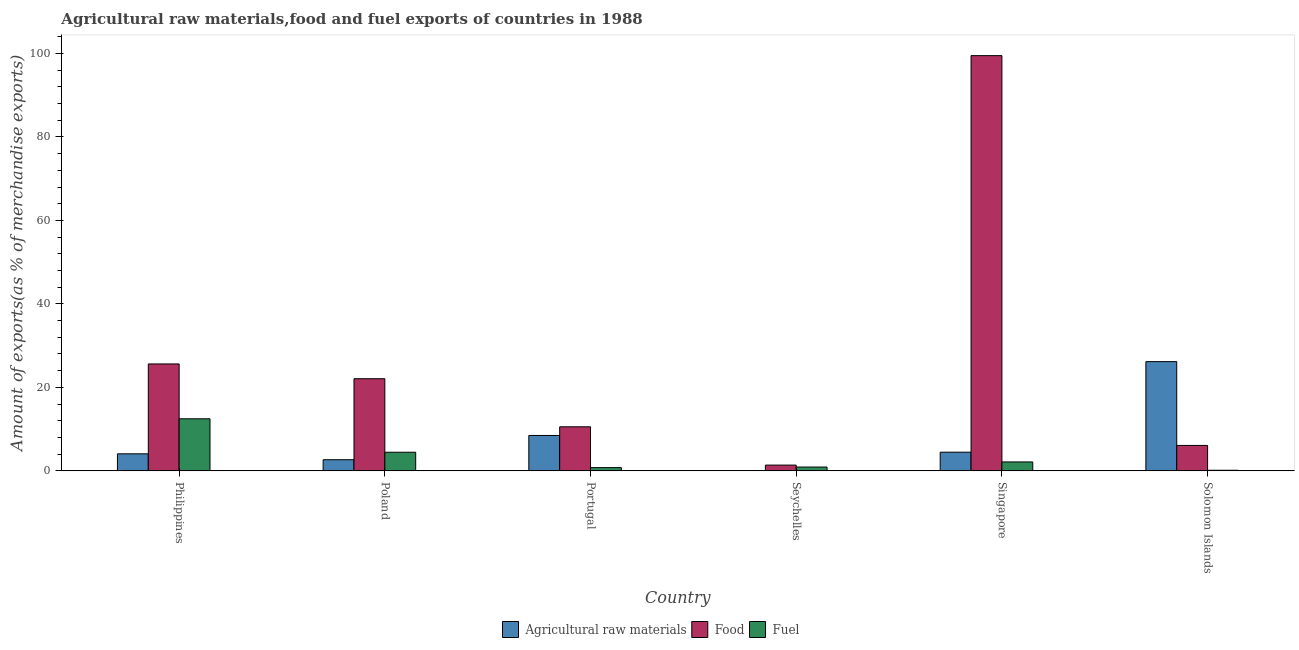How many different coloured bars are there?
Offer a terse response. 3. Are the number of bars per tick equal to the number of legend labels?
Give a very brief answer. Yes. How many bars are there on the 2nd tick from the right?
Your answer should be very brief. 3. What is the label of the 5th group of bars from the left?
Your answer should be very brief. Singapore. What is the percentage of food exports in Poland?
Give a very brief answer. 22.07. Across all countries, what is the maximum percentage of raw materials exports?
Your response must be concise. 26.16. Across all countries, what is the minimum percentage of raw materials exports?
Keep it short and to the point. 0.05. In which country was the percentage of raw materials exports maximum?
Ensure brevity in your answer.  Solomon Islands. In which country was the percentage of food exports minimum?
Make the answer very short. Seychelles. What is the total percentage of raw materials exports in the graph?
Offer a terse response. 45.89. What is the difference between the percentage of raw materials exports in Philippines and that in Solomon Islands?
Your answer should be very brief. -22.09. What is the difference between the percentage of raw materials exports in Seychelles and the percentage of fuel exports in Philippines?
Provide a succinct answer. -12.42. What is the average percentage of food exports per country?
Give a very brief answer. 27.53. What is the difference between the percentage of fuel exports and percentage of raw materials exports in Philippines?
Provide a short and direct response. 8.39. What is the ratio of the percentage of raw materials exports in Philippines to that in Solomon Islands?
Offer a terse response. 0.16. What is the difference between the highest and the second highest percentage of fuel exports?
Keep it short and to the point. 8.02. What is the difference between the highest and the lowest percentage of fuel exports?
Your answer should be compact. 12.33. Is the sum of the percentage of fuel exports in Philippines and Singapore greater than the maximum percentage of food exports across all countries?
Keep it short and to the point. No. What does the 3rd bar from the left in Portugal represents?
Keep it short and to the point. Fuel. What does the 3rd bar from the right in Portugal represents?
Keep it short and to the point. Agricultural raw materials. How many bars are there?
Give a very brief answer. 18. Are all the bars in the graph horizontal?
Give a very brief answer. No. Are the values on the major ticks of Y-axis written in scientific E-notation?
Offer a very short reply. No. Does the graph contain any zero values?
Make the answer very short. No. Does the graph contain grids?
Provide a succinct answer. No. How many legend labels are there?
Offer a terse response. 3. What is the title of the graph?
Give a very brief answer. Agricultural raw materials,food and fuel exports of countries in 1988. What is the label or title of the Y-axis?
Your answer should be compact. Amount of exports(as % of merchandise exports). What is the Amount of exports(as % of merchandise exports) of Agricultural raw materials in Philippines?
Provide a short and direct response. 4.08. What is the Amount of exports(as % of merchandise exports) of Food in Philippines?
Make the answer very short. 25.62. What is the Amount of exports(as % of merchandise exports) in Fuel in Philippines?
Provide a succinct answer. 12.47. What is the Amount of exports(as % of merchandise exports) in Agricultural raw materials in Poland?
Provide a succinct answer. 2.66. What is the Amount of exports(as % of merchandise exports) in Food in Poland?
Provide a short and direct response. 22.07. What is the Amount of exports(as % of merchandise exports) in Fuel in Poland?
Give a very brief answer. 4.45. What is the Amount of exports(as % of merchandise exports) in Agricultural raw materials in Portugal?
Offer a terse response. 8.47. What is the Amount of exports(as % of merchandise exports) of Food in Portugal?
Keep it short and to the point. 10.55. What is the Amount of exports(as % of merchandise exports) of Fuel in Portugal?
Offer a very short reply. 0.77. What is the Amount of exports(as % of merchandise exports) in Agricultural raw materials in Seychelles?
Give a very brief answer. 0.05. What is the Amount of exports(as % of merchandise exports) of Food in Seychelles?
Make the answer very short. 1.37. What is the Amount of exports(as % of merchandise exports) in Fuel in Seychelles?
Give a very brief answer. 0.91. What is the Amount of exports(as % of merchandise exports) of Agricultural raw materials in Singapore?
Your answer should be very brief. 4.47. What is the Amount of exports(as % of merchandise exports) of Food in Singapore?
Your answer should be compact. 99.49. What is the Amount of exports(as % of merchandise exports) of Fuel in Singapore?
Offer a terse response. 2.13. What is the Amount of exports(as % of merchandise exports) in Agricultural raw materials in Solomon Islands?
Offer a very short reply. 26.16. What is the Amount of exports(as % of merchandise exports) in Food in Solomon Islands?
Give a very brief answer. 6.09. What is the Amount of exports(as % of merchandise exports) in Fuel in Solomon Islands?
Provide a short and direct response. 0.14. Across all countries, what is the maximum Amount of exports(as % of merchandise exports) of Agricultural raw materials?
Give a very brief answer. 26.16. Across all countries, what is the maximum Amount of exports(as % of merchandise exports) of Food?
Make the answer very short. 99.49. Across all countries, what is the maximum Amount of exports(as % of merchandise exports) of Fuel?
Keep it short and to the point. 12.47. Across all countries, what is the minimum Amount of exports(as % of merchandise exports) of Agricultural raw materials?
Offer a terse response. 0.05. Across all countries, what is the minimum Amount of exports(as % of merchandise exports) of Food?
Offer a very short reply. 1.37. Across all countries, what is the minimum Amount of exports(as % of merchandise exports) in Fuel?
Offer a terse response. 0.14. What is the total Amount of exports(as % of merchandise exports) of Agricultural raw materials in the graph?
Offer a terse response. 45.89. What is the total Amount of exports(as % of merchandise exports) of Food in the graph?
Your answer should be compact. 165.19. What is the total Amount of exports(as % of merchandise exports) of Fuel in the graph?
Provide a succinct answer. 20.87. What is the difference between the Amount of exports(as % of merchandise exports) of Agricultural raw materials in Philippines and that in Poland?
Your answer should be very brief. 1.42. What is the difference between the Amount of exports(as % of merchandise exports) of Food in Philippines and that in Poland?
Give a very brief answer. 3.54. What is the difference between the Amount of exports(as % of merchandise exports) in Fuel in Philippines and that in Poland?
Offer a very short reply. 8.02. What is the difference between the Amount of exports(as % of merchandise exports) of Agricultural raw materials in Philippines and that in Portugal?
Your answer should be very brief. -4.4. What is the difference between the Amount of exports(as % of merchandise exports) in Food in Philippines and that in Portugal?
Your response must be concise. 15.07. What is the difference between the Amount of exports(as % of merchandise exports) of Fuel in Philippines and that in Portugal?
Your response must be concise. 11.7. What is the difference between the Amount of exports(as % of merchandise exports) in Agricultural raw materials in Philippines and that in Seychelles?
Offer a terse response. 4.03. What is the difference between the Amount of exports(as % of merchandise exports) of Food in Philippines and that in Seychelles?
Ensure brevity in your answer.  24.24. What is the difference between the Amount of exports(as % of merchandise exports) of Fuel in Philippines and that in Seychelles?
Provide a short and direct response. 11.56. What is the difference between the Amount of exports(as % of merchandise exports) of Agricultural raw materials in Philippines and that in Singapore?
Your answer should be very brief. -0.39. What is the difference between the Amount of exports(as % of merchandise exports) of Food in Philippines and that in Singapore?
Provide a short and direct response. -73.87. What is the difference between the Amount of exports(as % of merchandise exports) in Fuel in Philippines and that in Singapore?
Make the answer very short. 10.34. What is the difference between the Amount of exports(as % of merchandise exports) in Agricultural raw materials in Philippines and that in Solomon Islands?
Your answer should be compact. -22.09. What is the difference between the Amount of exports(as % of merchandise exports) of Food in Philippines and that in Solomon Islands?
Give a very brief answer. 19.53. What is the difference between the Amount of exports(as % of merchandise exports) of Fuel in Philippines and that in Solomon Islands?
Offer a very short reply. 12.33. What is the difference between the Amount of exports(as % of merchandise exports) of Agricultural raw materials in Poland and that in Portugal?
Ensure brevity in your answer.  -5.81. What is the difference between the Amount of exports(as % of merchandise exports) of Food in Poland and that in Portugal?
Your answer should be very brief. 11.52. What is the difference between the Amount of exports(as % of merchandise exports) of Fuel in Poland and that in Portugal?
Make the answer very short. 3.68. What is the difference between the Amount of exports(as % of merchandise exports) of Agricultural raw materials in Poland and that in Seychelles?
Keep it short and to the point. 2.61. What is the difference between the Amount of exports(as % of merchandise exports) of Food in Poland and that in Seychelles?
Offer a terse response. 20.7. What is the difference between the Amount of exports(as % of merchandise exports) of Fuel in Poland and that in Seychelles?
Offer a very short reply. 3.54. What is the difference between the Amount of exports(as % of merchandise exports) of Agricultural raw materials in Poland and that in Singapore?
Offer a terse response. -1.8. What is the difference between the Amount of exports(as % of merchandise exports) in Food in Poland and that in Singapore?
Provide a short and direct response. -77.42. What is the difference between the Amount of exports(as % of merchandise exports) of Fuel in Poland and that in Singapore?
Make the answer very short. 2.32. What is the difference between the Amount of exports(as % of merchandise exports) in Agricultural raw materials in Poland and that in Solomon Islands?
Your answer should be compact. -23.5. What is the difference between the Amount of exports(as % of merchandise exports) of Food in Poland and that in Solomon Islands?
Offer a very short reply. 15.99. What is the difference between the Amount of exports(as % of merchandise exports) of Fuel in Poland and that in Solomon Islands?
Keep it short and to the point. 4.32. What is the difference between the Amount of exports(as % of merchandise exports) in Agricultural raw materials in Portugal and that in Seychelles?
Your answer should be very brief. 8.43. What is the difference between the Amount of exports(as % of merchandise exports) in Food in Portugal and that in Seychelles?
Offer a terse response. 9.18. What is the difference between the Amount of exports(as % of merchandise exports) in Fuel in Portugal and that in Seychelles?
Ensure brevity in your answer.  -0.14. What is the difference between the Amount of exports(as % of merchandise exports) in Agricultural raw materials in Portugal and that in Singapore?
Ensure brevity in your answer.  4.01. What is the difference between the Amount of exports(as % of merchandise exports) in Food in Portugal and that in Singapore?
Offer a terse response. -88.94. What is the difference between the Amount of exports(as % of merchandise exports) of Fuel in Portugal and that in Singapore?
Your response must be concise. -1.36. What is the difference between the Amount of exports(as % of merchandise exports) in Agricultural raw materials in Portugal and that in Solomon Islands?
Give a very brief answer. -17.69. What is the difference between the Amount of exports(as % of merchandise exports) of Food in Portugal and that in Solomon Islands?
Keep it short and to the point. 4.46. What is the difference between the Amount of exports(as % of merchandise exports) of Fuel in Portugal and that in Solomon Islands?
Offer a terse response. 0.64. What is the difference between the Amount of exports(as % of merchandise exports) of Agricultural raw materials in Seychelles and that in Singapore?
Provide a succinct answer. -4.42. What is the difference between the Amount of exports(as % of merchandise exports) of Food in Seychelles and that in Singapore?
Your answer should be compact. -98.12. What is the difference between the Amount of exports(as % of merchandise exports) in Fuel in Seychelles and that in Singapore?
Provide a short and direct response. -1.22. What is the difference between the Amount of exports(as % of merchandise exports) in Agricultural raw materials in Seychelles and that in Solomon Islands?
Your answer should be compact. -26.12. What is the difference between the Amount of exports(as % of merchandise exports) in Food in Seychelles and that in Solomon Islands?
Your response must be concise. -4.71. What is the difference between the Amount of exports(as % of merchandise exports) in Fuel in Seychelles and that in Solomon Islands?
Your response must be concise. 0.77. What is the difference between the Amount of exports(as % of merchandise exports) of Agricultural raw materials in Singapore and that in Solomon Islands?
Your answer should be very brief. -21.7. What is the difference between the Amount of exports(as % of merchandise exports) in Food in Singapore and that in Solomon Islands?
Offer a very short reply. 93.4. What is the difference between the Amount of exports(as % of merchandise exports) in Fuel in Singapore and that in Solomon Islands?
Your answer should be very brief. 1.99. What is the difference between the Amount of exports(as % of merchandise exports) in Agricultural raw materials in Philippines and the Amount of exports(as % of merchandise exports) in Food in Poland?
Your response must be concise. -18. What is the difference between the Amount of exports(as % of merchandise exports) of Agricultural raw materials in Philippines and the Amount of exports(as % of merchandise exports) of Fuel in Poland?
Make the answer very short. -0.38. What is the difference between the Amount of exports(as % of merchandise exports) of Food in Philippines and the Amount of exports(as % of merchandise exports) of Fuel in Poland?
Your answer should be very brief. 21.16. What is the difference between the Amount of exports(as % of merchandise exports) of Agricultural raw materials in Philippines and the Amount of exports(as % of merchandise exports) of Food in Portugal?
Your answer should be very brief. -6.47. What is the difference between the Amount of exports(as % of merchandise exports) of Agricultural raw materials in Philippines and the Amount of exports(as % of merchandise exports) of Fuel in Portugal?
Keep it short and to the point. 3.31. What is the difference between the Amount of exports(as % of merchandise exports) in Food in Philippines and the Amount of exports(as % of merchandise exports) in Fuel in Portugal?
Keep it short and to the point. 24.84. What is the difference between the Amount of exports(as % of merchandise exports) of Agricultural raw materials in Philippines and the Amount of exports(as % of merchandise exports) of Food in Seychelles?
Keep it short and to the point. 2.7. What is the difference between the Amount of exports(as % of merchandise exports) in Agricultural raw materials in Philippines and the Amount of exports(as % of merchandise exports) in Fuel in Seychelles?
Make the answer very short. 3.17. What is the difference between the Amount of exports(as % of merchandise exports) in Food in Philippines and the Amount of exports(as % of merchandise exports) in Fuel in Seychelles?
Provide a short and direct response. 24.71. What is the difference between the Amount of exports(as % of merchandise exports) of Agricultural raw materials in Philippines and the Amount of exports(as % of merchandise exports) of Food in Singapore?
Keep it short and to the point. -95.41. What is the difference between the Amount of exports(as % of merchandise exports) in Agricultural raw materials in Philippines and the Amount of exports(as % of merchandise exports) in Fuel in Singapore?
Offer a terse response. 1.95. What is the difference between the Amount of exports(as % of merchandise exports) in Food in Philippines and the Amount of exports(as % of merchandise exports) in Fuel in Singapore?
Provide a short and direct response. 23.49. What is the difference between the Amount of exports(as % of merchandise exports) of Agricultural raw materials in Philippines and the Amount of exports(as % of merchandise exports) of Food in Solomon Islands?
Your answer should be very brief. -2.01. What is the difference between the Amount of exports(as % of merchandise exports) in Agricultural raw materials in Philippines and the Amount of exports(as % of merchandise exports) in Fuel in Solomon Islands?
Make the answer very short. 3.94. What is the difference between the Amount of exports(as % of merchandise exports) of Food in Philippines and the Amount of exports(as % of merchandise exports) of Fuel in Solomon Islands?
Your answer should be compact. 25.48. What is the difference between the Amount of exports(as % of merchandise exports) of Agricultural raw materials in Poland and the Amount of exports(as % of merchandise exports) of Food in Portugal?
Provide a short and direct response. -7.89. What is the difference between the Amount of exports(as % of merchandise exports) in Agricultural raw materials in Poland and the Amount of exports(as % of merchandise exports) in Fuel in Portugal?
Offer a terse response. 1.89. What is the difference between the Amount of exports(as % of merchandise exports) of Food in Poland and the Amount of exports(as % of merchandise exports) of Fuel in Portugal?
Make the answer very short. 21.3. What is the difference between the Amount of exports(as % of merchandise exports) in Agricultural raw materials in Poland and the Amount of exports(as % of merchandise exports) in Food in Seychelles?
Offer a terse response. 1.29. What is the difference between the Amount of exports(as % of merchandise exports) of Agricultural raw materials in Poland and the Amount of exports(as % of merchandise exports) of Fuel in Seychelles?
Your response must be concise. 1.75. What is the difference between the Amount of exports(as % of merchandise exports) of Food in Poland and the Amount of exports(as % of merchandise exports) of Fuel in Seychelles?
Provide a succinct answer. 21.16. What is the difference between the Amount of exports(as % of merchandise exports) in Agricultural raw materials in Poland and the Amount of exports(as % of merchandise exports) in Food in Singapore?
Your response must be concise. -96.83. What is the difference between the Amount of exports(as % of merchandise exports) in Agricultural raw materials in Poland and the Amount of exports(as % of merchandise exports) in Fuel in Singapore?
Your response must be concise. 0.53. What is the difference between the Amount of exports(as % of merchandise exports) in Food in Poland and the Amount of exports(as % of merchandise exports) in Fuel in Singapore?
Give a very brief answer. 19.94. What is the difference between the Amount of exports(as % of merchandise exports) in Agricultural raw materials in Poland and the Amount of exports(as % of merchandise exports) in Food in Solomon Islands?
Offer a terse response. -3.43. What is the difference between the Amount of exports(as % of merchandise exports) in Agricultural raw materials in Poland and the Amount of exports(as % of merchandise exports) in Fuel in Solomon Islands?
Offer a terse response. 2.52. What is the difference between the Amount of exports(as % of merchandise exports) of Food in Poland and the Amount of exports(as % of merchandise exports) of Fuel in Solomon Islands?
Make the answer very short. 21.94. What is the difference between the Amount of exports(as % of merchandise exports) of Agricultural raw materials in Portugal and the Amount of exports(as % of merchandise exports) of Food in Seychelles?
Provide a short and direct response. 7.1. What is the difference between the Amount of exports(as % of merchandise exports) of Agricultural raw materials in Portugal and the Amount of exports(as % of merchandise exports) of Fuel in Seychelles?
Give a very brief answer. 7.57. What is the difference between the Amount of exports(as % of merchandise exports) in Food in Portugal and the Amount of exports(as % of merchandise exports) in Fuel in Seychelles?
Offer a terse response. 9.64. What is the difference between the Amount of exports(as % of merchandise exports) of Agricultural raw materials in Portugal and the Amount of exports(as % of merchandise exports) of Food in Singapore?
Give a very brief answer. -91.02. What is the difference between the Amount of exports(as % of merchandise exports) of Agricultural raw materials in Portugal and the Amount of exports(as % of merchandise exports) of Fuel in Singapore?
Keep it short and to the point. 6.35. What is the difference between the Amount of exports(as % of merchandise exports) in Food in Portugal and the Amount of exports(as % of merchandise exports) in Fuel in Singapore?
Your answer should be very brief. 8.42. What is the difference between the Amount of exports(as % of merchandise exports) of Agricultural raw materials in Portugal and the Amount of exports(as % of merchandise exports) of Food in Solomon Islands?
Make the answer very short. 2.39. What is the difference between the Amount of exports(as % of merchandise exports) of Agricultural raw materials in Portugal and the Amount of exports(as % of merchandise exports) of Fuel in Solomon Islands?
Offer a terse response. 8.34. What is the difference between the Amount of exports(as % of merchandise exports) in Food in Portugal and the Amount of exports(as % of merchandise exports) in Fuel in Solomon Islands?
Offer a terse response. 10.41. What is the difference between the Amount of exports(as % of merchandise exports) of Agricultural raw materials in Seychelles and the Amount of exports(as % of merchandise exports) of Food in Singapore?
Make the answer very short. -99.44. What is the difference between the Amount of exports(as % of merchandise exports) in Agricultural raw materials in Seychelles and the Amount of exports(as % of merchandise exports) in Fuel in Singapore?
Offer a very short reply. -2.08. What is the difference between the Amount of exports(as % of merchandise exports) in Food in Seychelles and the Amount of exports(as % of merchandise exports) in Fuel in Singapore?
Keep it short and to the point. -0.76. What is the difference between the Amount of exports(as % of merchandise exports) in Agricultural raw materials in Seychelles and the Amount of exports(as % of merchandise exports) in Food in Solomon Islands?
Your answer should be compact. -6.04. What is the difference between the Amount of exports(as % of merchandise exports) in Agricultural raw materials in Seychelles and the Amount of exports(as % of merchandise exports) in Fuel in Solomon Islands?
Give a very brief answer. -0.09. What is the difference between the Amount of exports(as % of merchandise exports) of Food in Seychelles and the Amount of exports(as % of merchandise exports) of Fuel in Solomon Islands?
Your response must be concise. 1.24. What is the difference between the Amount of exports(as % of merchandise exports) in Agricultural raw materials in Singapore and the Amount of exports(as % of merchandise exports) in Food in Solomon Islands?
Your answer should be very brief. -1.62. What is the difference between the Amount of exports(as % of merchandise exports) of Agricultural raw materials in Singapore and the Amount of exports(as % of merchandise exports) of Fuel in Solomon Islands?
Provide a short and direct response. 4.33. What is the difference between the Amount of exports(as % of merchandise exports) of Food in Singapore and the Amount of exports(as % of merchandise exports) of Fuel in Solomon Islands?
Provide a short and direct response. 99.35. What is the average Amount of exports(as % of merchandise exports) in Agricultural raw materials per country?
Provide a short and direct response. 7.65. What is the average Amount of exports(as % of merchandise exports) in Food per country?
Provide a short and direct response. 27.53. What is the average Amount of exports(as % of merchandise exports) in Fuel per country?
Offer a very short reply. 3.48. What is the difference between the Amount of exports(as % of merchandise exports) in Agricultural raw materials and Amount of exports(as % of merchandise exports) in Food in Philippines?
Offer a terse response. -21.54. What is the difference between the Amount of exports(as % of merchandise exports) of Agricultural raw materials and Amount of exports(as % of merchandise exports) of Fuel in Philippines?
Keep it short and to the point. -8.39. What is the difference between the Amount of exports(as % of merchandise exports) of Food and Amount of exports(as % of merchandise exports) of Fuel in Philippines?
Provide a succinct answer. 13.15. What is the difference between the Amount of exports(as % of merchandise exports) in Agricultural raw materials and Amount of exports(as % of merchandise exports) in Food in Poland?
Give a very brief answer. -19.41. What is the difference between the Amount of exports(as % of merchandise exports) of Agricultural raw materials and Amount of exports(as % of merchandise exports) of Fuel in Poland?
Give a very brief answer. -1.79. What is the difference between the Amount of exports(as % of merchandise exports) of Food and Amount of exports(as % of merchandise exports) of Fuel in Poland?
Offer a terse response. 17.62. What is the difference between the Amount of exports(as % of merchandise exports) of Agricultural raw materials and Amount of exports(as % of merchandise exports) of Food in Portugal?
Give a very brief answer. -2.08. What is the difference between the Amount of exports(as % of merchandise exports) of Agricultural raw materials and Amount of exports(as % of merchandise exports) of Fuel in Portugal?
Keep it short and to the point. 7.7. What is the difference between the Amount of exports(as % of merchandise exports) in Food and Amount of exports(as % of merchandise exports) in Fuel in Portugal?
Keep it short and to the point. 9.78. What is the difference between the Amount of exports(as % of merchandise exports) of Agricultural raw materials and Amount of exports(as % of merchandise exports) of Food in Seychelles?
Your answer should be very brief. -1.32. What is the difference between the Amount of exports(as % of merchandise exports) of Agricultural raw materials and Amount of exports(as % of merchandise exports) of Fuel in Seychelles?
Your answer should be compact. -0.86. What is the difference between the Amount of exports(as % of merchandise exports) of Food and Amount of exports(as % of merchandise exports) of Fuel in Seychelles?
Provide a succinct answer. 0.46. What is the difference between the Amount of exports(as % of merchandise exports) of Agricultural raw materials and Amount of exports(as % of merchandise exports) of Food in Singapore?
Your answer should be compact. -95.03. What is the difference between the Amount of exports(as % of merchandise exports) in Agricultural raw materials and Amount of exports(as % of merchandise exports) in Fuel in Singapore?
Keep it short and to the point. 2.34. What is the difference between the Amount of exports(as % of merchandise exports) in Food and Amount of exports(as % of merchandise exports) in Fuel in Singapore?
Your response must be concise. 97.36. What is the difference between the Amount of exports(as % of merchandise exports) of Agricultural raw materials and Amount of exports(as % of merchandise exports) of Food in Solomon Islands?
Offer a terse response. 20.08. What is the difference between the Amount of exports(as % of merchandise exports) in Agricultural raw materials and Amount of exports(as % of merchandise exports) in Fuel in Solomon Islands?
Provide a short and direct response. 26.03. What is the difference between the Amount of exports(as % of merchandise exports) of Food and Amount of exports(as % of merchandise exports) of Fuel in Solomon Islands?
Ensure brevity in your answer.  5.95. What is the ratio of the Amount of exports(as % of merchandise exports) in Agricultural raw materials in Philippines to that in Poland?
Keep it short and to the point. 1.53. What is the ratio of the Amount of exports(as % of merchandise exports) of Food in Philippines to that in Poland?
Offer a terse response. 1.16. What is the ratio of the Amount of exports(as % of merchandise exports) in Fuel in Philippines to that in Poland?
Offer a very short reply. 2.8. What is the ratio of the Amount of exports(as % of merchandise exports) of Agricultural raw materials in Philippines to that in Portugal?
Provide a succinct answer. 0.48. What is the ratio of the Amount of exports(as % of merchandise exports) of Food in Philippines to that in Portugal?
Keep it short and to the point. 2.43. What is the ratio of the Amount of exports(as % of merchandise exports) in Fuel in Philippines to that in Portugal?
Make the answer very short. 16.17. What is the ratio of the Amount of exports(as % of merchandise exports) in Agricultural raw materials in Philippines to that in Seychelles?
Your answer should be very brief. 86.02. What is the ratio of the Amount of exports(as % of merchandise exports) of Food in Philippines to that in Seychelles?
Your answer should be compact. 18.68. What is the ratio of the Amount of exports(as % of merchandise exports) in Fuel in Philippines to that in Seychelles?
Provide a short and direct response. 13.71. What is the ratio of the Amount of exports(as % of merchandise exports) of Agricultural raw materials in Philippines to that in Singapore?
Your answer should be very brief. 0.91. What is the ratio of the Amount of exports(as % of merchandise exports) in Food in Philippines to that in Singapore?
Offer a very short reply. 0.26. What is the ratio of the Amount of exports(as % of merchandise exports) in Fuel in Philippines to that in Singapore?
Your response must be concise. 5.86. What is the ratio of the Amount of exports(as % of merchandise exports) in Agricultural raw materials in Philippines to that in Solomon Islands?
Your response must be concise. 0.16. What is the ratio of the Amount of exports(as % of merchandise exports) of Food in Philippines to that in Solomon Islands?
Provide a succinct answer. 4.21. What is the ratio of the Amount of exports(as % of merchandise exports) in Fuel in Philippines to that in Solomon Islands?
Give a very brief answer. 91.8. What is the ratio of the Amount of exports(as % of merchandise exports) in Agricultural raw materials in Poland to that in Portugal?
Give a very brief answer. 0.31. What is the ratio of the Amount of exports(as % of merchandise exports) of Food in Poland to that in Portugal?
Your answer should be compact. 2.09. What is the ratio of the Amount of exports(as % of merchandise exports) of Fuel in Poland to that in Portugal?
Offer a very short reply. 5.78. What is the ratio of the Amount of exports(as % of merchandise exports) of Agricultural raw materials in Poland to that in Seychelles?
Your answer should be compact. 56.14. What is the ratio of the Amount of exports(as % of merchandise exports) in Food in Poland to that in Seychelles?
Your response must be concise. 16.1. What is the ratio of the Amount of exports(as % of merchandise exports) of Fuel in Poland to that in Seychelles?
Offer a very short reply. 4.9. What is the ratio of the Amount of exports(as % of merchandise exports) of Agricultural raw materials in Poland to that in Singapore?
Offer a terse response. 0.6. What is the ratio of the Amount of exports(as % of merchandise exports) in Food in Poland to that in Singapore?
Make the answer very short. 0.22. What is the ratio of the Amount of exports(as % of merchandise exports) of Fuel in Poland to that in Singapore?
Make the answer very short. 2.09. What is the ratio of the Amount of exports(as % of merchandise exports) of Agricultural raw materials in Poland to that in Solomon Islands?
Your response must be concise. 0.1. What is the ratio of the Amount of exports(as % of merchandise exports) of Food in Poland to that in Solomon Islands?
Provide a succinct answer. 3.63. What is the ratio of the Amount of exports(as % of merchandise exports) in Fuel in Poland to that in Solomon Islands?
Your answer should be very brief. 32.79. What is the ratio of the Amount of exports(as % of merchandise exports) in Agricultural raw materials in Portugal to that in Seychelles?
Your answer should be compact. 178.84. What is the ratio of the Amount of exports(as % of merchandise exports) of Food in Portugal to that in Seychelles?
Provide a succinct answer. 7.69. What is the ratio of the Amount of exports(as % of merchandise exports) of Fuel in Portugal to that in Seychelles?
Give a very brief answer. 0.85. What is the ratio of the Amount of exports(as % of merchandise exports) in Agricultural raw materials in Portugal to that in Singapore?
Offer a terse response. 1.9. What is the ratio of the Amount of exports(as % of merchandise exports) in Food in Portugal to that in Singapore?
Keep it short and to the point. 0.11. What is the ratio of the Amount of exports(as % of merchandise exports) in Fuel in Portugal to that in Singapore?
Provide a succinct answer. 0.36. What is the ratio of the Amount of exports(as % of merchandise exports) in Agricultural raw materials in Portugal to that in Solomon Islands?
Provide a short and direct response. 0.32. What is the ratio of the Amount of exports(as % of merchandise exports) of Food in Portugal to that in Solomon Islands?
Provide a succinct answer. 1.73. What is the ratio of the Amount of exports(as % of merchandise exports) of Fuel in Portugal to that in Solomon Islands?
Your answer should be compact. 5.68. What is the ratio of the Amount of exports(as % of merchandise exports) of Agricultural raw materials in Seychelles to that in Singapore?
Keep it short and to the point. 0.01. What is the ratio of the Amount of exports(as % of merchandise exports) in Food in Seychelles to that in Singapore?
Give a very brief answer. 0.01. What is the ratio of the Amount of exports(as % of merchandise exports) of Fuel in Seychelles to that in Singapore?
Offer a terse response. 0.43. What is the ratio of the Amount of exports(as % of merchandise exports) of Agricultural raw materials in Seychelles to that in Solomon Islands?
Keep it short and to the point. 0. What is the ratio of the Amount of exports(as % of merchandise exports) of Food in Seychelles to that in Solomon Islands?
Your answer should be very brief. 0.23. What is the ratio of the Amount of exports(as % of merchandise exports) of Fuel in Seychelles to that in Solomon Islands?
Ensure brevity in your answer.  6.69. What is the ratio of the Amount of exports(as % of merchandise exports) in Agricultural raw materials in Singapore to that in Solomon Islands?
Your answer should be compact. 0.17. What is the ratio of the Amount of exports(as % of merchandise exports) in Food in Singapore to that in Solomon Islands?
Ensure brevity in your answer.  16.35. What is the ratio of the Amount of exports(as % of merchandise exports) in Fuel in Singapore to that in Solomon Islands?
Keep it short and to the point. 15.67. What is the difference between the highest and the second highest Amount of exports(as % of merchandise exports) in Agricultural raw materials?
Give a very brief answer. 17.69. What is the difference between the highest and the second highest Amount of exports(as % of merchandise exports) of Food?
Offer a very short reply. 73.87. What is the difference between the highest and the second highest Amount of exports(as % of merchandise exports) of Fuel?
Give a very brief answer. 8.02. What is the difference between the highest and the lowest Amount of exports(as % of merchandise exports) of Agricultural raw materials?
Offer a very short reply. 26.12. What is the difference between the highest and the lowest Amount of exports(as % of merchandise exports) of Food?
Give a very brief answer. 98.12. What is the difference between the highest and the lowest Amount of exports(as % of merchandise exports) of Fuel?
Your answer should be compact. 12.33. 